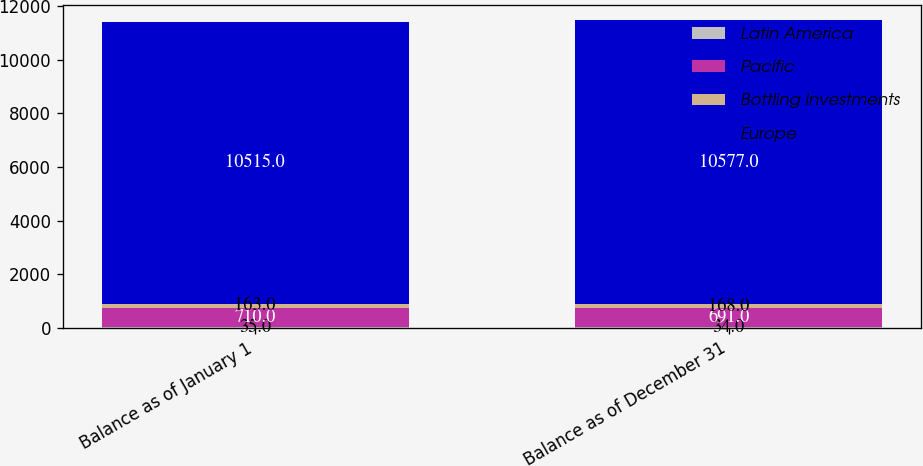<chart> <loc_0><loc_0><loc_500><loc_500><stacked_bar_chart><ecel><fcel>Balance as of January 1<fcel>Balance as of December 31<nl><fcel>Latin America<fcel>35<fcel>34<nl><fcel>Pacific<fcel>710<fcel>691<nl><fcel>Bottling Investments<fcel>163<fcel>168<nl><fcel>Europe<fcel>10515<fcel>10577<nl></chart> 